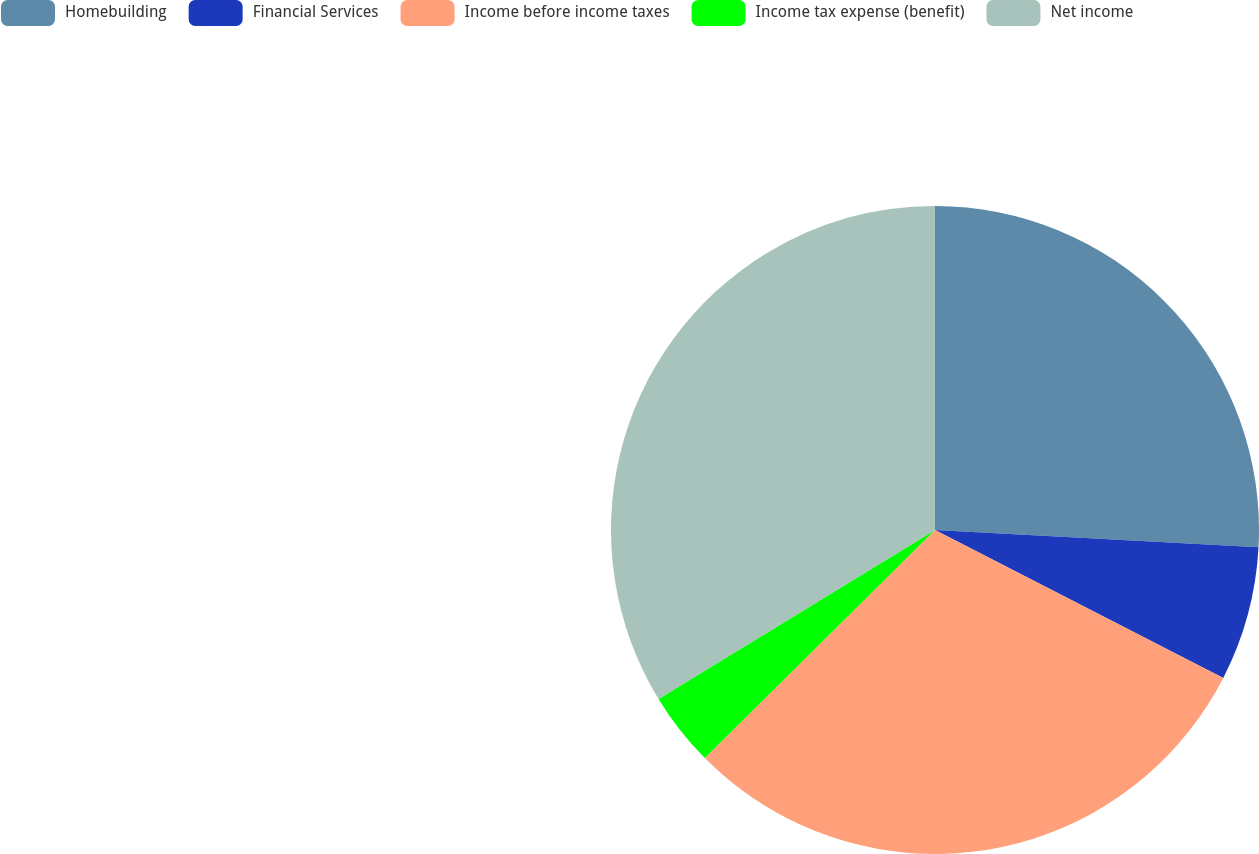<chart> <loc_0><loc_0><loc_500><loc_500><pie_chart><fcel>Homebuilding<fcel>Financial Services<fcel>Income before income taxes<fcel>Income tax expense (benefit)<fcel>Net income<nl><fcel>25.85%<fcel>6.7%<fcel>30.03%<fcel>3.7%<fcel>33.73%<nl></chart> 